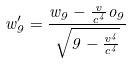<formula> <loc_0><loc_0><loc_500><loc_500>w _ { 9 } ^ { \prime } = \frac { w _ { 9 } - \frac { v } { c ^ { 4 } } o _ { 9 } } { \sqrt { 9 - \frac { v ^ { 4 } } { c ^ { 4 } } } }</formula> 